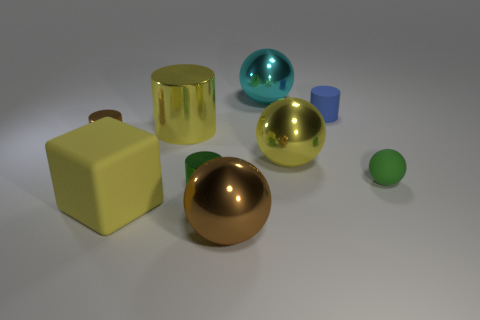How many other things are the same shape as the big brown thing?
Make the answer very short. 3. There is a big yellow shiny ball; what number of large objects are on the right side of it?
Your response must be concise. 0. Is the number of yellow metal spheres that are behind the rubber cube less than the number of cylinders in front of the blue cylinder?
Provide a succinct answer. Yes. The brown thing in front of the brown object that is behind the yellow thing that is on the right side of the green metal cylinder is what shape?
Your answer should be very brief. Sphere. What shape is the thing that is both on the left side of the big metal cylinder and on the right side of the small brown object?
Your answer should be very brief. Cube. Are there any green spheres that have the same material as the large brown object?
Keep it short and to the point. No. There is a metal sphere that is the same color as the big cylinder; what size is it?
Provide a succinct answer. Large. What is the color of the matte object to the left of the big brown metallic sphere?
Keep it short and to the point. Yellow. There is a tiny blue object; is it the same shape as the brown object in front of the tiny brown metallic thing?
Offer a terse response. No. Are there any objects that have the same color as the rubber ball?
Ensure brevity in your answer.  Yes. 